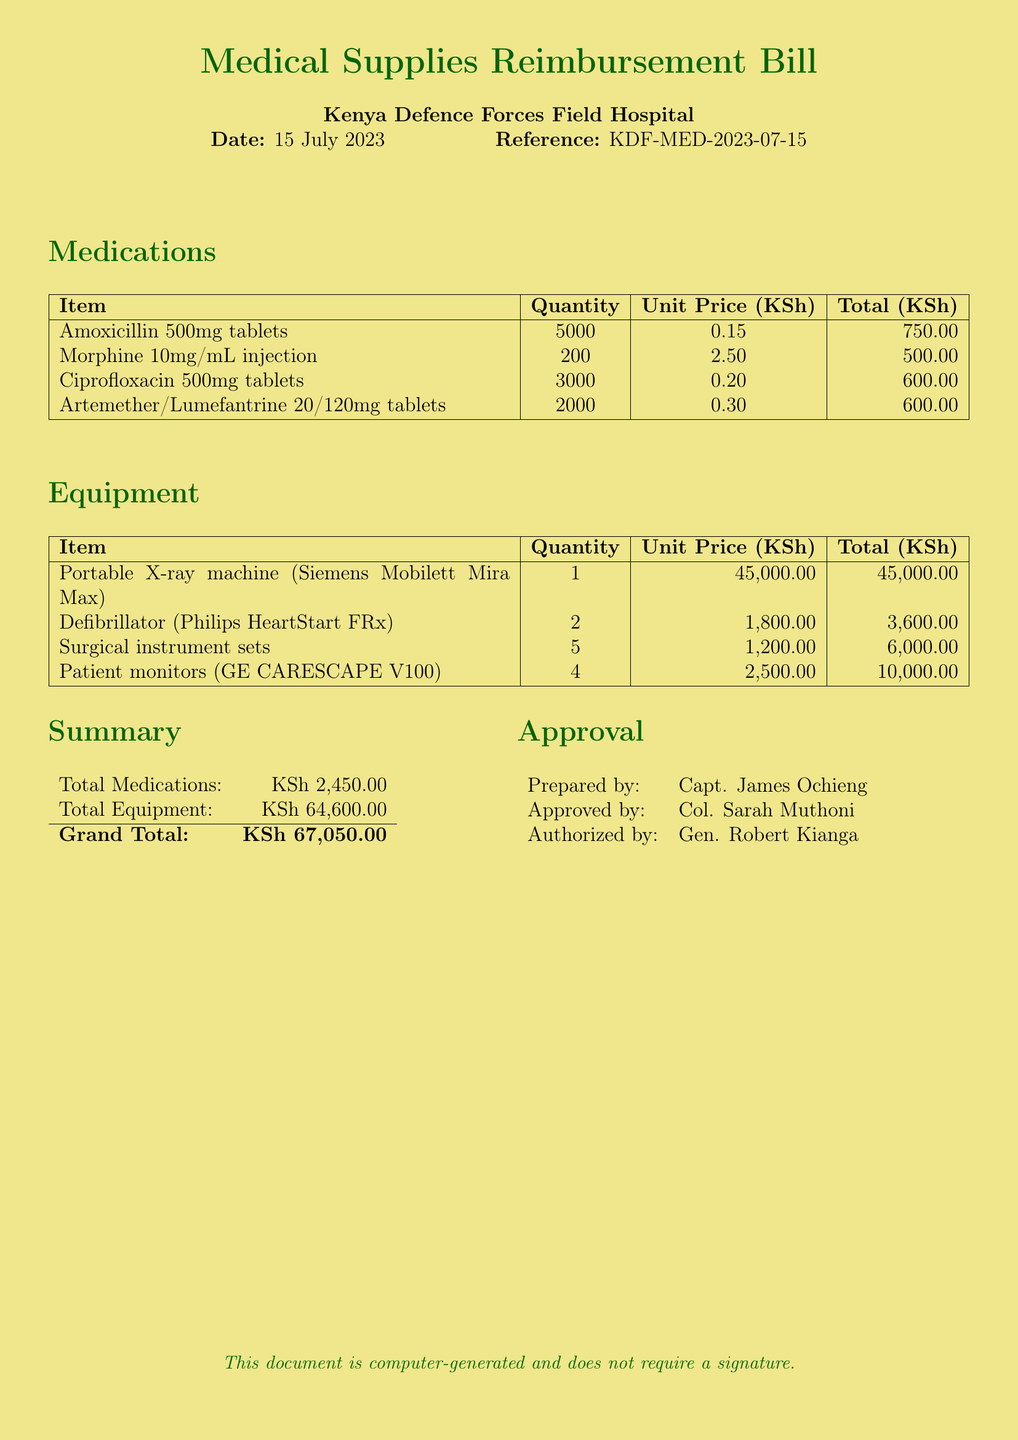What is the date of the bill? The date of the bill is mentioned at the top of the document as 15 July 2023.
Answer: 15 July 2023 Who prepared the document? The prepared by section lists Capt. James Ochieng as the person who prepared the document.
Answer: Capt. James Ochieng What is the total amount for medications? The total for medications is found in the summary section as KSh 2,450.00.
Answer: KSh 2,450.00 How many Portable X-ray machines were purchased? The equipment section lists 1 Portable X-ray machine purchased.
Answer: 1 What is the grand total of the bill? The grand total is calculated in the summary section and is listed as KSh 67,050.00.
Answer: KSh 67,050.00 How many defibrillators were ordered? The equipment table specifies the quantity of defibrillators ordered as 2.
Answer: 2 What is the unit price of Morphine per injection? The medications table indicates the unit price of Morphine per injection is KSh 2.50.
Answer: KSh 2.50 Which item had the highest unit price? By comparing the unit prices in the equipment section, the item with the highest unit price is the Portable X-ray machine at KSh 45,000.00.
Answer: Portable X-ray machine Who authorized the document? The authorization section lists Gen. Robert Kianga as the person who authorized the document.
Answer: Gen. Robert Kianga 